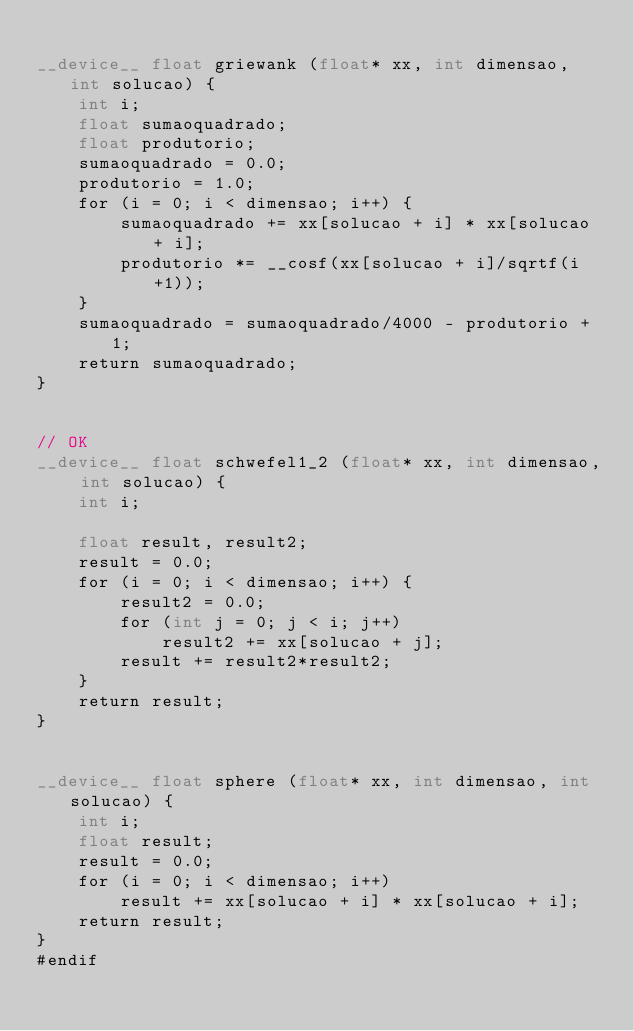<code> <loc_0><loc_0><loc_500><loc_500><_Cuda_>
__device__ float griewank (float* xx, int dimensao, int solucao) {
	int i;
	float sumaoquadrado;
	float produtorio;
	sumaoquadrado = 0.0;
	produtorio = 1.0;
	for (i = 0; i < dimensao; i++) {
		sumaoquadrado += xx[solucao + i] * xx[solucao + i];
		produtorio *= __cosf(xx[solucao + i]/sqrtf(i+1));
	}
	sumaoquadrado = sumaoquadrado/4000 - produtorio + 1;
	return sumaoquadrado;
}


// OK
__device__ float schwefel1_2 (float* xx, int dimensao, int solucao) {
	int i;

	float result, result2;
	result = 0.0;
	for (i = 0; i < dimensao; i++) {
		result2 = 0.0;
		for (int j = 0; j < i; j++)
			result2 += xx[solucao + j];
		result += result2*result2;
	}
	return result;
}


__device__ float sphere (float* xx, int dimensao, int solucao) {
	int i;
	float result;
	result = 0.0;
	for (i = 0; i < dimensao; i++)
		result += xx[solucao + i] * xx[solucao + i];
	return result;
}
#endif
</code> 